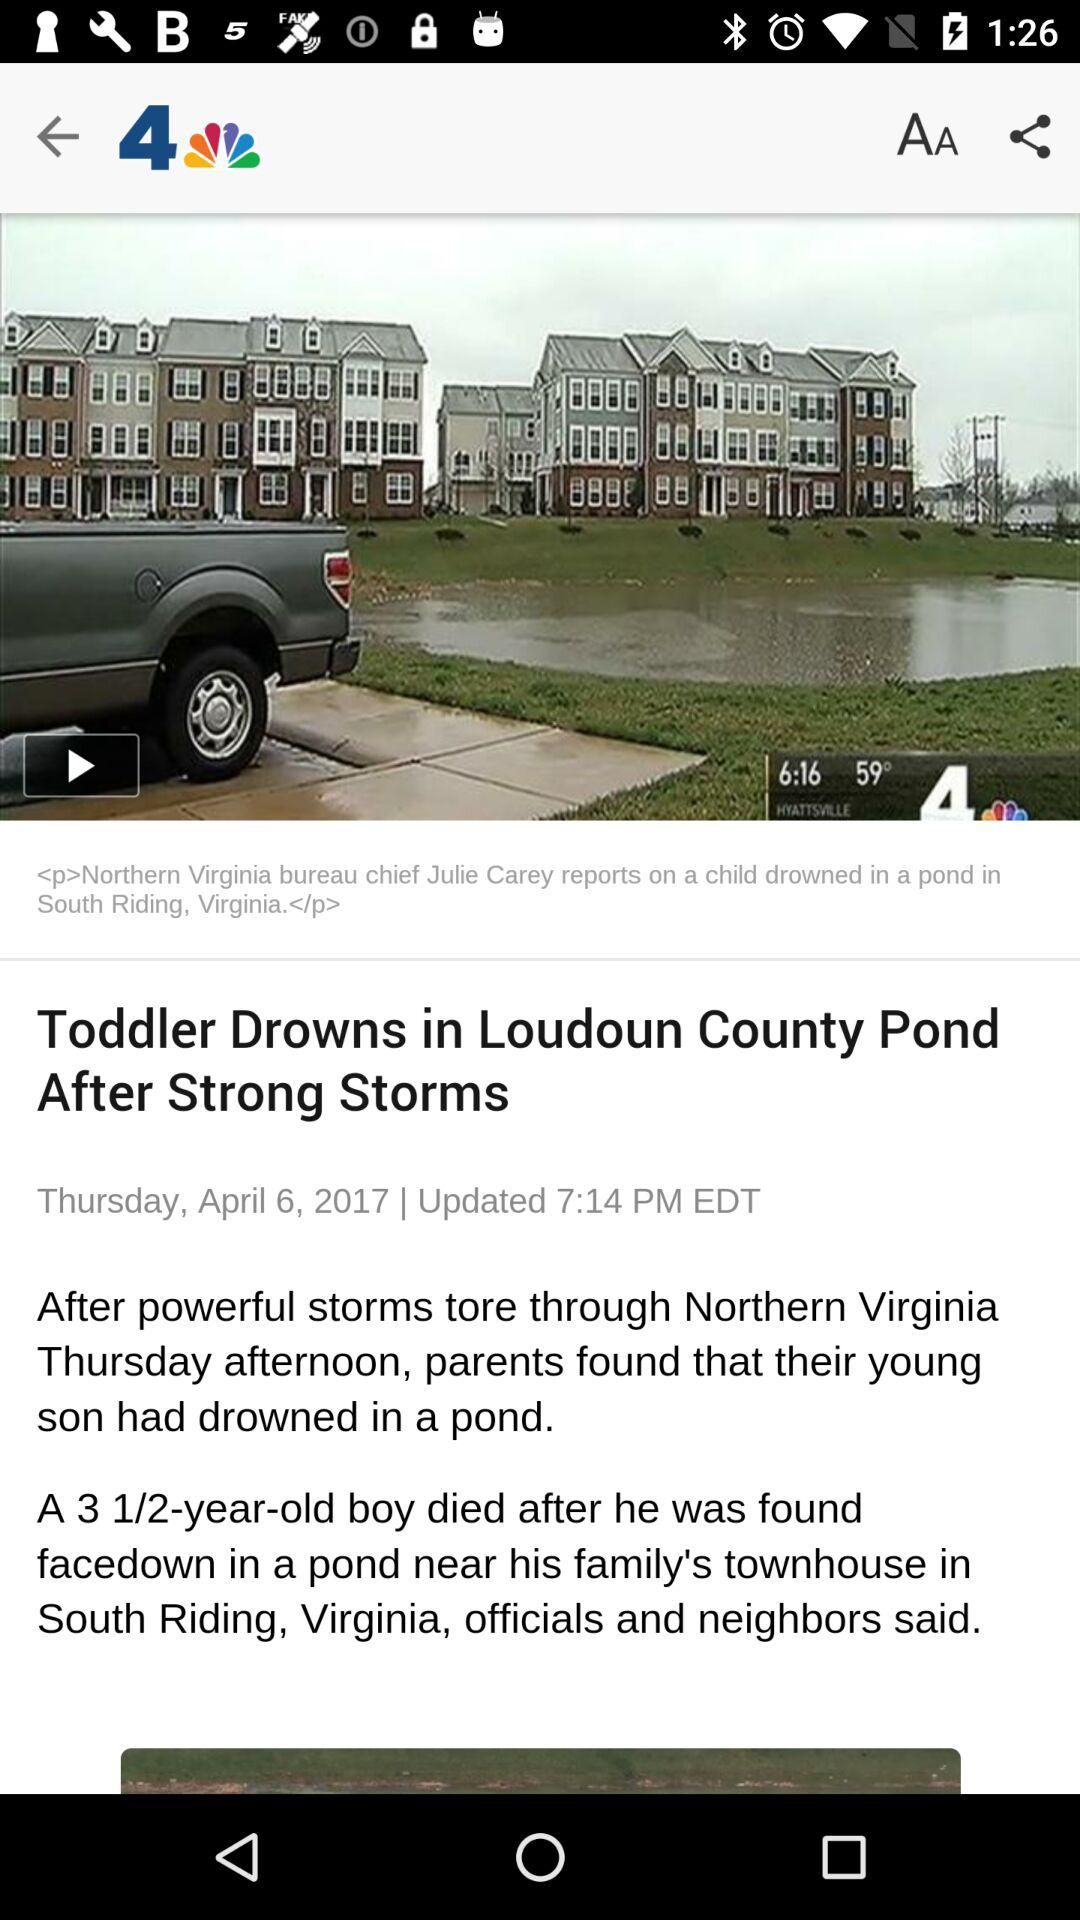What is the headline? The headline is "Toddler Drowns in Loudoun County Pond After Strong Storms". 